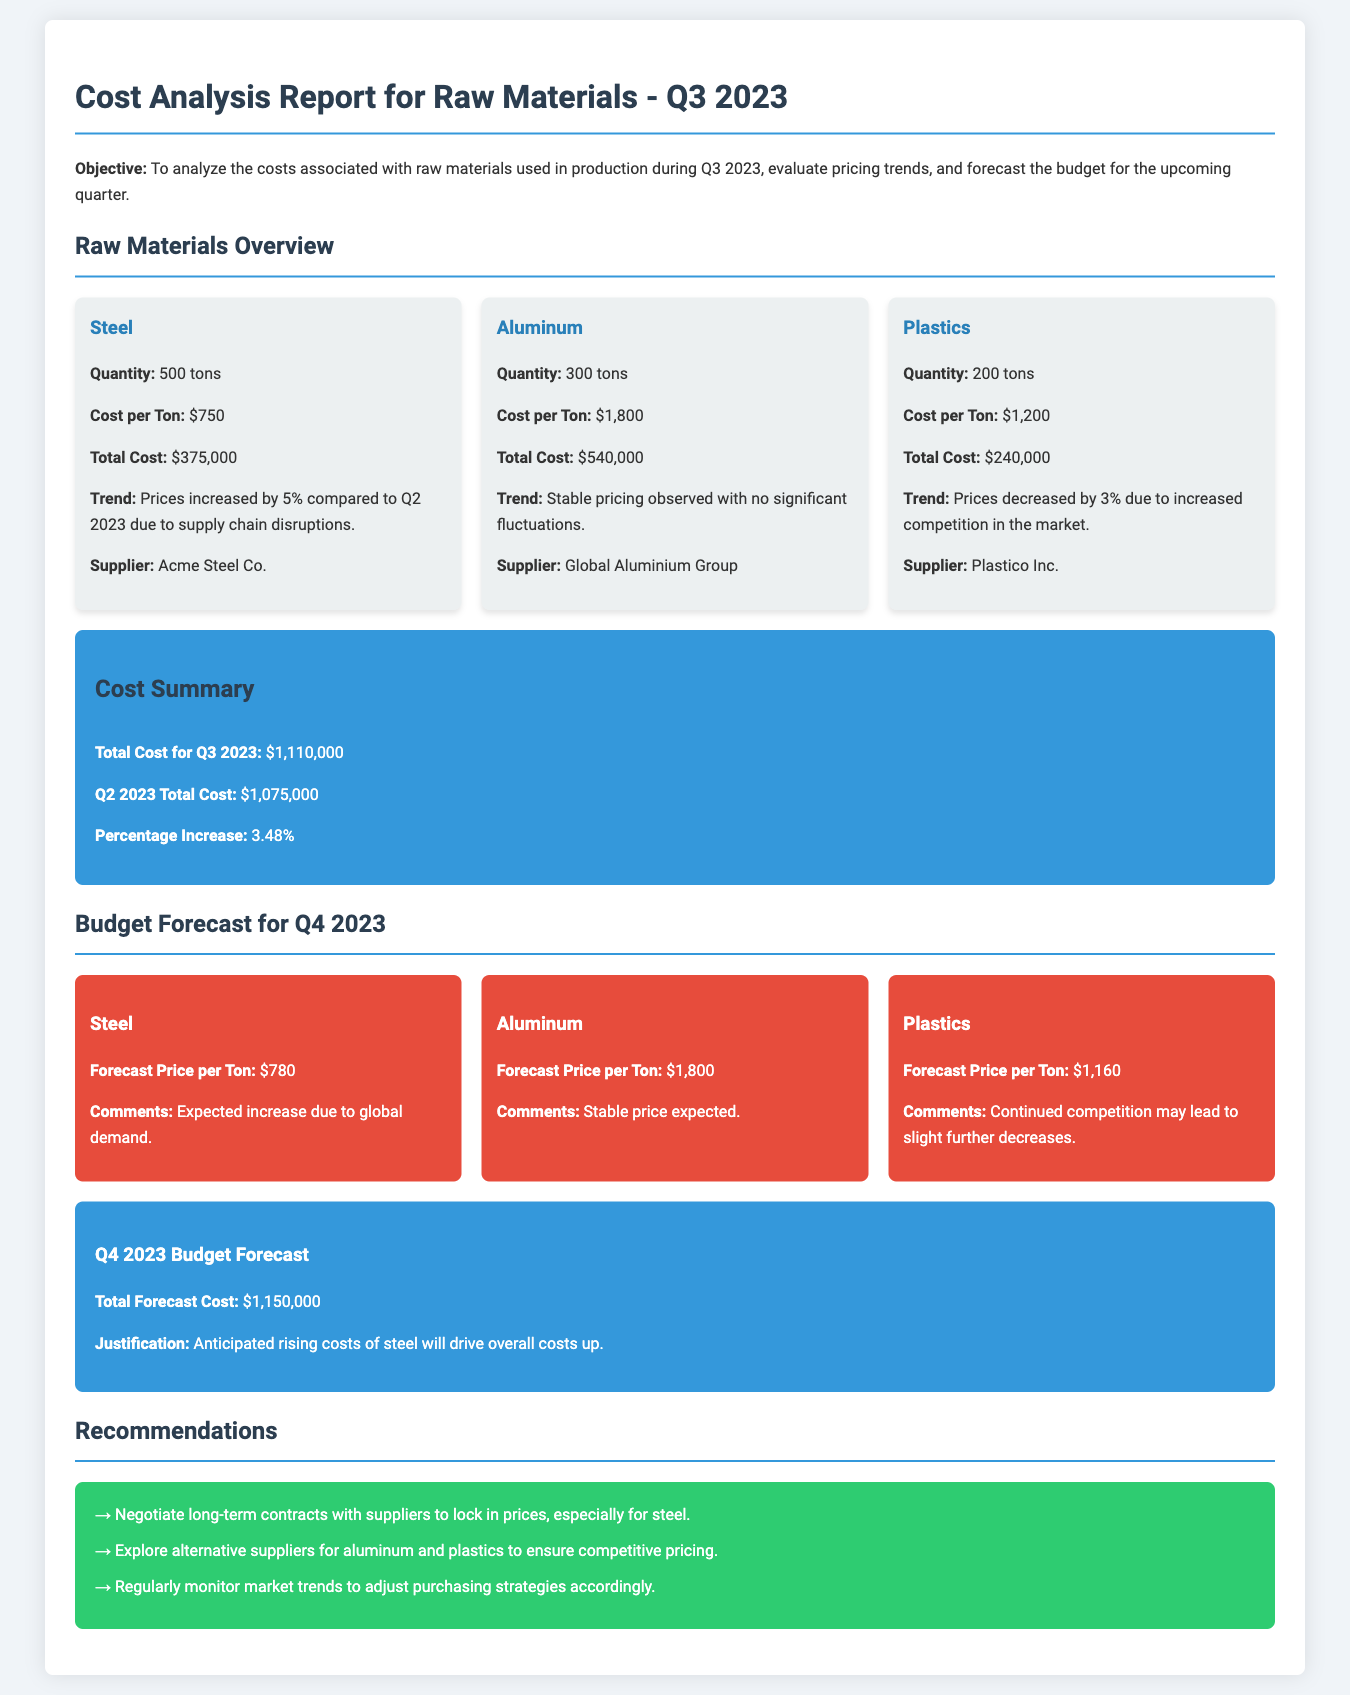What is the total cost for Q3 2023? The total cost for Q3 2023 is stated in the summary box of the document.
Answer: $1,110,000 What was the cost per ton of steel? The cost per ton of steel is mentioned in the raw materials overview.
Answer: $750 Which supplier provided aluminum? The supplier for aluminum is listed under the aluminum material card.
Answer: Global Aluminium Group What was the percentage increase in costs compared to Q2 2023? The percentage increase is provided in the cost summary section.
Answer: 3.48% What is the forecast price per ton of plastics for Q4 2023? The forecast price is mentioned in the budget forecast section for plastics.
Answer: $1,160 Why is the total forecast cost for Q4 2023 expected to rise? The justification for the cost forecast is explained in the summary box for Q4 2023.
Answer: Anticipated rising costs of steel What recommendation is given regarding steel suppliers? The recommendations section suggests actions regarding suppliers.
Answer: Negotiate long-term contracts with suppliers to lock in prices, especially for steel 